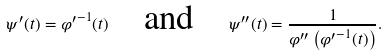Convert formula to latex. <formula><loc_0><loc_0><loc_500><loc_500>\psi ^ { \prime } ( t ) = { \varphi ^ { \prime } } ^ { - 1 } ( t ) \quad \text {and} \quad \psi ^ { \prime \prime } ( t ) = \frac { 1 } { \varphi ^ { \prime \prime } \left ( { \varphi ^ { \prime } } ^ { - 1 } ( t ) \right ) } .</formula> 